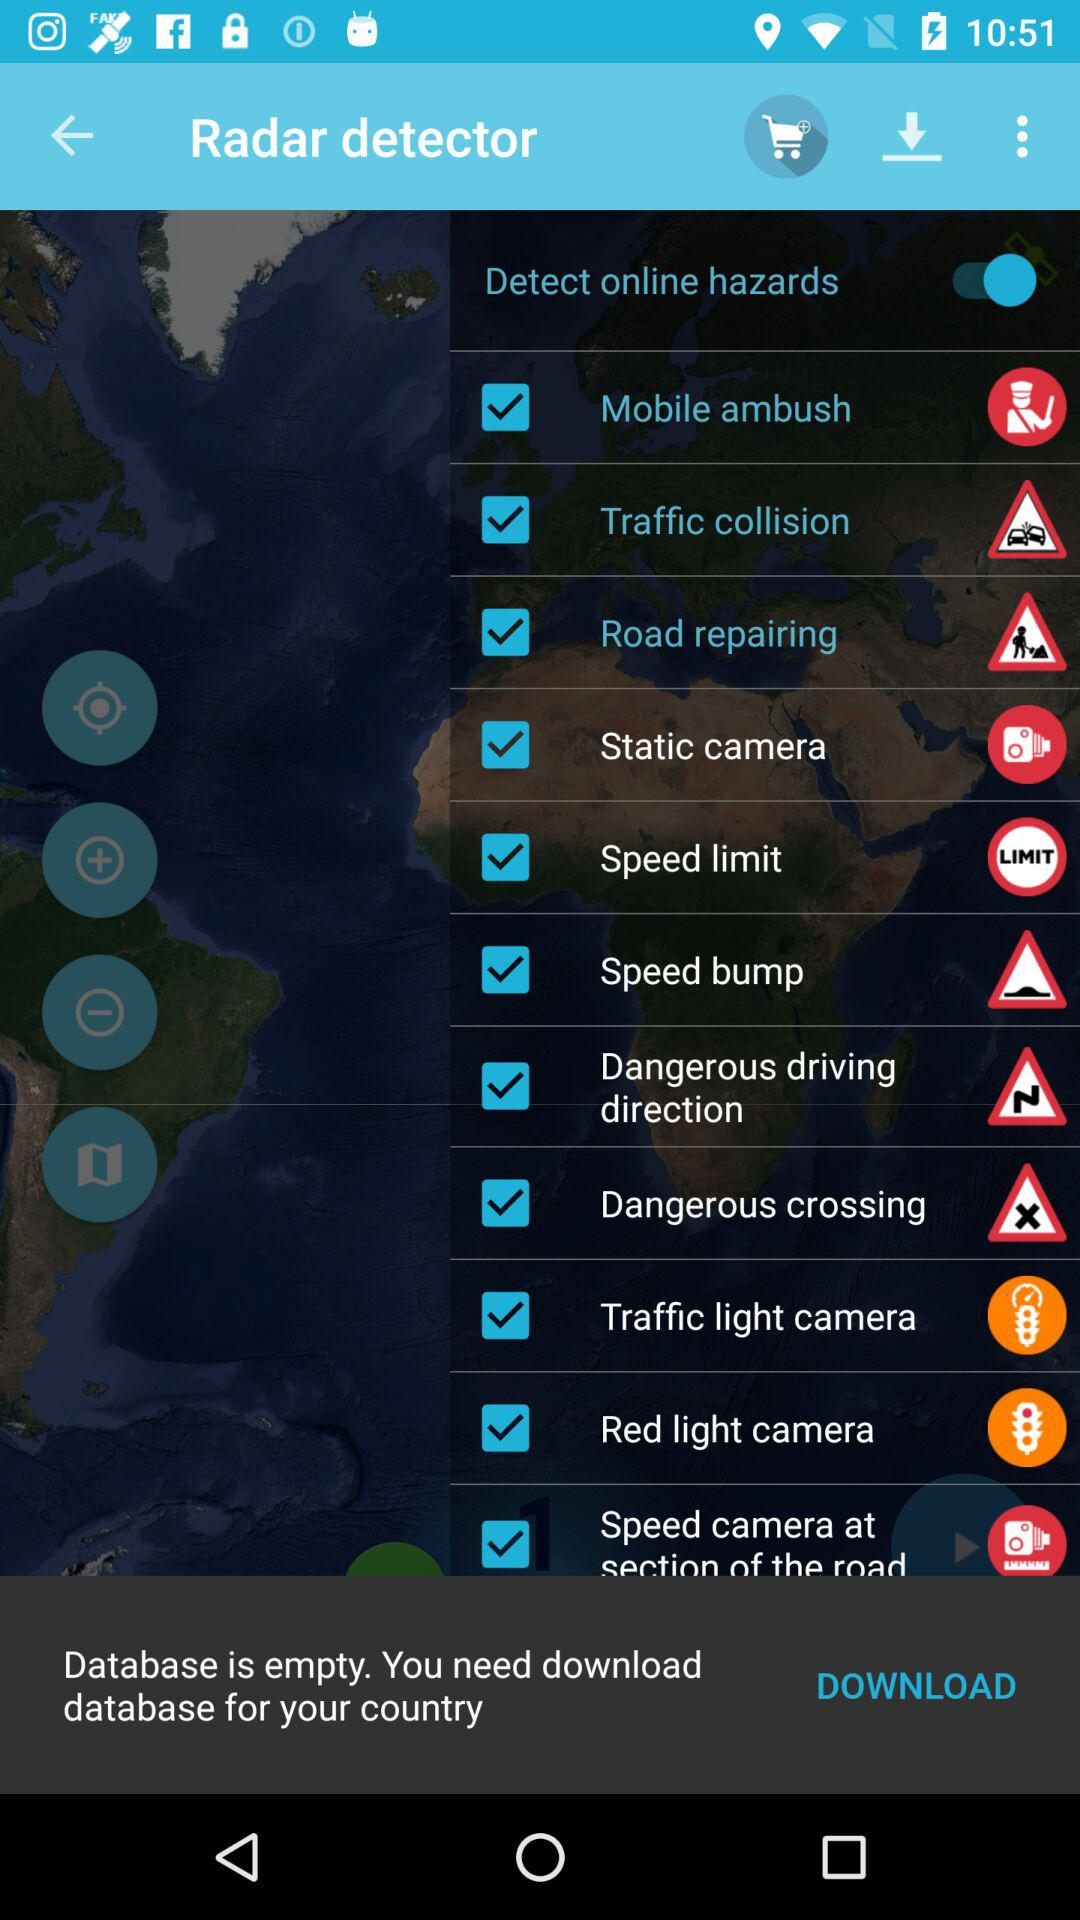What is the status of the "Detect online hazards"? The status is "on". 